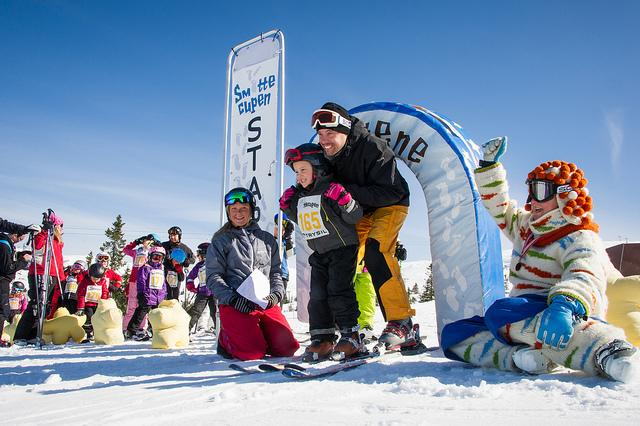Why are the children wearing numbers on their jackets?

Choices:
A) for fun
B) for style
C) as punishment
D) for competition for competition 